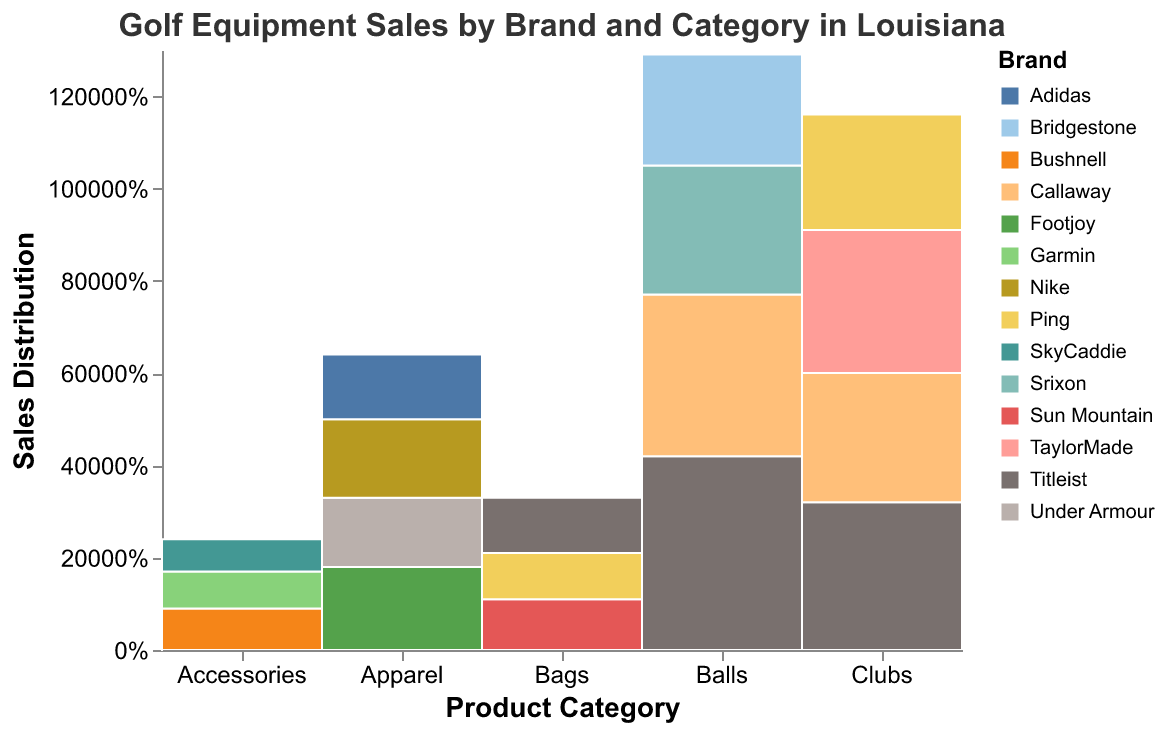What's the highest-selling brand for clubs? The highest bar under the "Clubs" category represents Titleist, with sales reaching 320. This is higher than the sales of Callaway, TaylorMade, and Ping.
Answer: Titleist Among all brands in the apparel category, which one has the lowest sales? The smallest section under the "Apparel" category is labeled Adidas, indicating the lowest sales value.
Answer: Adidas How do Titleist's sales in the balls category compare to Bridgestone's sales in the same category? Titleist's bar is significantly larger than Bridgestone's in the "Balls" category. Titleist has 420 sales and Bridgestone has 240 sales, so Titleist's sales are 180 units higher than Bridgestone's.
Answer: Titleist's sales are higher by 180 units If you sum up the sales of all brands in the accessories category, what total do you get? The individual sales in the "Accessories" category are Bushnell (90), Garmin (80), and SkyCaddie (70). Summing these values: 90 + 80 + 70 = 240.
Answer: 240 Within the bags category, which brand shows the second highest sales? For the "Bags" category, the sales are Titleist (120), Ping (100), and Sun Mountain (110). The second highest sales value is Sun Mountain with 110.
Answer: Sun Mountain Which category has the highest overall sales? Comparing the total heights of all the bars in each category, the "Balls" category has the highest cumulative height, indicating the highest overall sales.
Answer: Balls What is the sales difference between the top-selling and the lowest-selling brand in the clubs category? The top-selling brand in the "Clubs" category is Titleist with 320 sales, and the lowest-selling is Ping with 250 sales. The difference is: 320 - 250 = 70.
Answer: 70 Are the sales of golf balls higher for Callaway or Srixon? Comparing the "Balls" category for Callaway and Srixon, Callaway has higher sales with 350 compared to Srixon's 280.
Answer: Callaway What proportion of the total sales in apparel is contributed by Nike? The total sales in "Apparel" can be calculated by adding the sales of Footjoy (180), Under Armour (150), Nike (170), and Adidas (140). Total apparel sales = 180 + 150 + 170 + 140 = 640. Therefore, Nike's proportion is 170/640 = 0.265 or approximately 26.5%.
Answer: 26.5% 